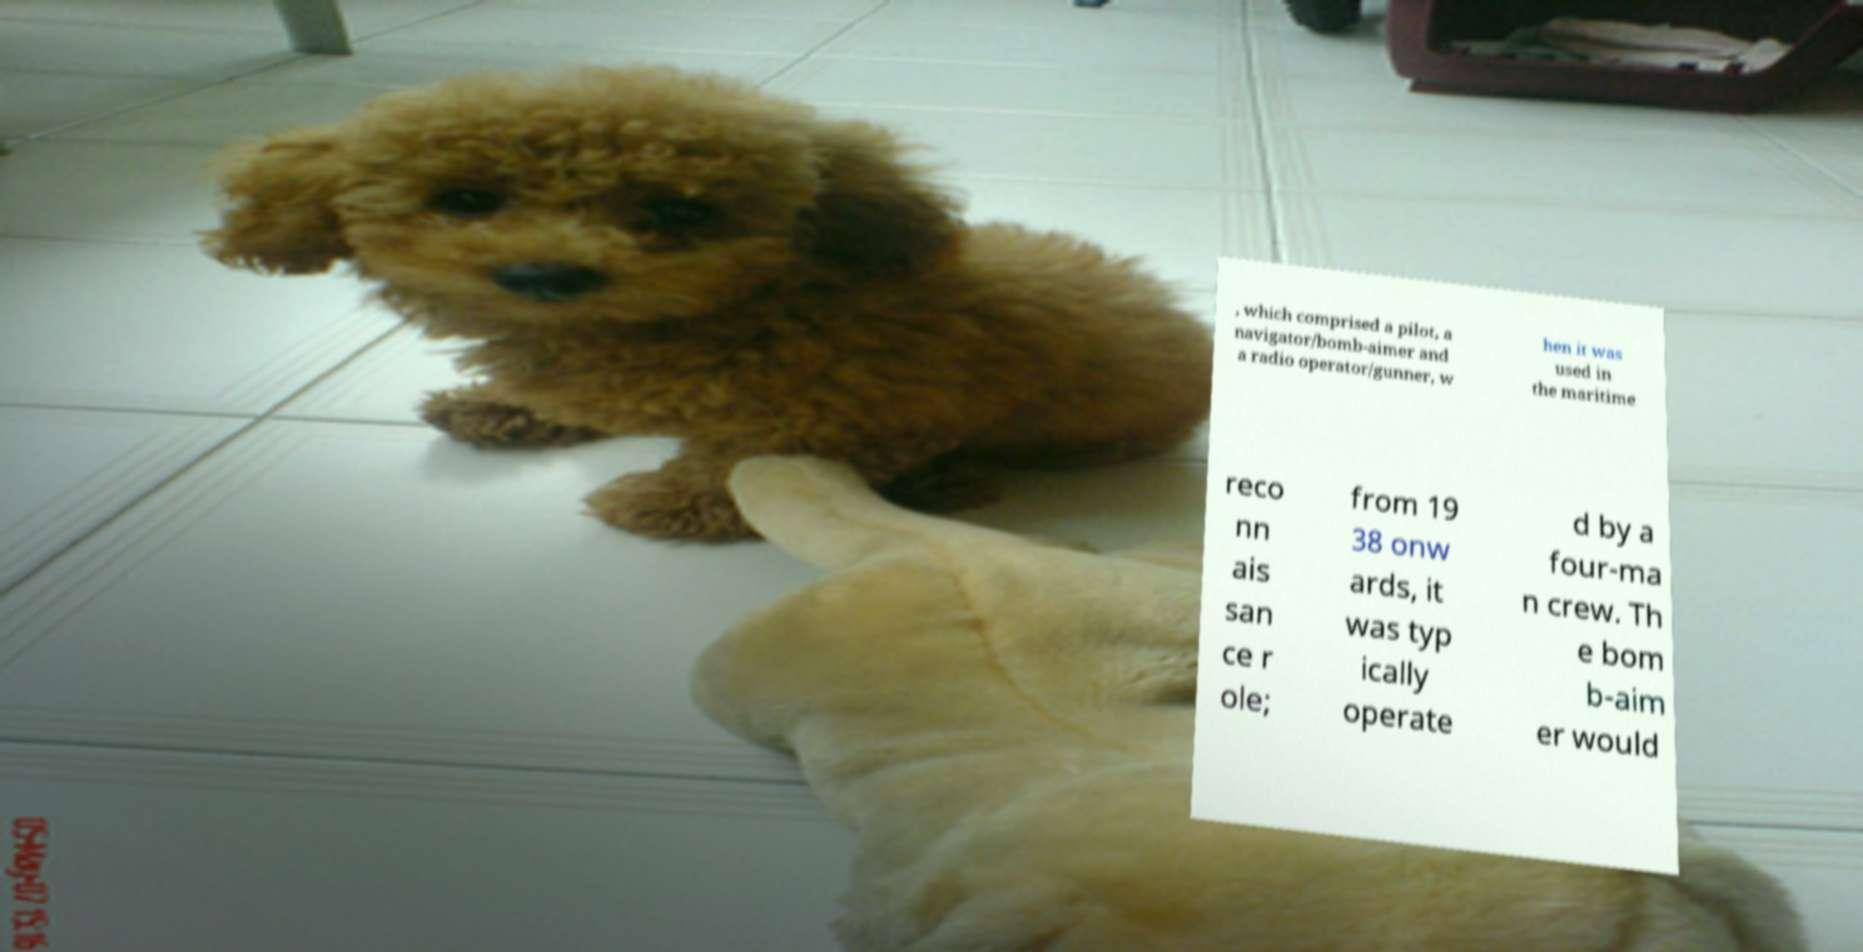For documentation purposes, I need the text within this image transcribed. Could you provide that? , which comprised a pilot, a navigator/bomb-aimer and a radio operator/gunner, w hen it was used in the maritime reco nn ais san ce r ole; from 19 38 onw ards, it was typ ically operate d by a four-ma n crew. Th e bom b-aim er would 